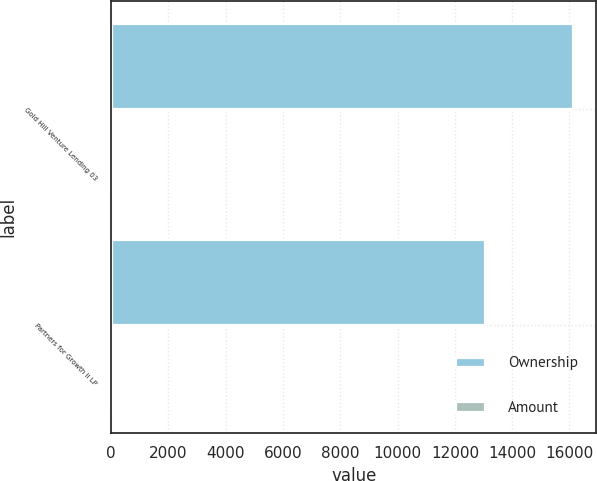Convert chart. <chart><loc_0><loc_0><loc_500><loc_500><stacked_bar_chart><ecel><fcel>Gold Hill Venture Lending 03<fcel>Partners for Growth II LP<nl><fcel>Ownership<fcel>16134<fcel>13059<nl><fcel>Amount<fcel>9.3<fcel>24.2<nl></chart> 